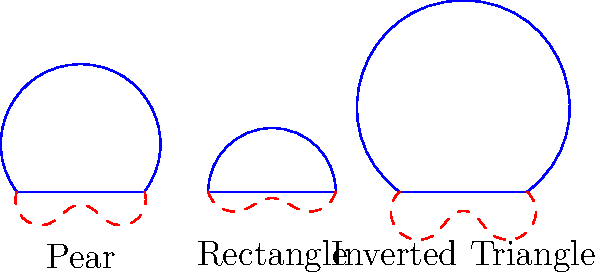In the context of fabric draping and body movement, which body shape is likely to experience the most resistance during lateral arm movements when wearing a fitted garment, and why? To answer this question, we need to consider the relationship between body shape, fabric draping, and movement:

1. Analyze the body shapes:
   - Pear: Wider at the hips, narrower at the shoulders
   - Rectangle: Relatively straight from shoulders to hips
   - Inverted triangle: Wider at the shoulders, narrower at the hips

2. Consider fabric draping:
   - Fabric tends to follow the contours of the body
   - Areas with more curvature will have more fabric tension

3. Examine lateral arm movements:
   - Lateral arm movements primarily involve the upper body and shoulders
   - Resistance occurs when fabric is stretched or pulled tight

4. Evaluate each body shape:
   - Pear: Less fabric tension in the upper body, allowing for easier movement
   - Rectangle: Consistent fabric tension, moderate resistance
   - Inverted triangle: More fabric tension in the upper body due to wider shoulders

5. Conclusion:
   The inverted triangle body shape will likely experience the most resistance during lateral arm movements because:
   - The wider shoulders create more tension in the fabric around the upper body
   - During lateral arm movements, this tension will increase, causing more resistance
   - The fitted garment will have less give in the shoulder area compared to other body shapes
Answer: Inverted triangle body shape 